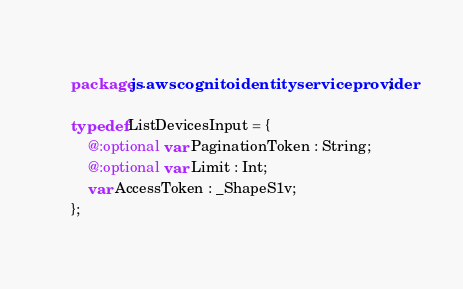Convert code to text. <code><loc_0><loc_0><loc_500><loc_500><_Haxe_>package js.aws.cognitoidentityserviceprovider;

typedef ListDevicesInput = {
    @:optional var PaginationToken : String;
    @:optional var Limit : Int;
    var AccessToken : _ShapeS1v;
};
</code> 